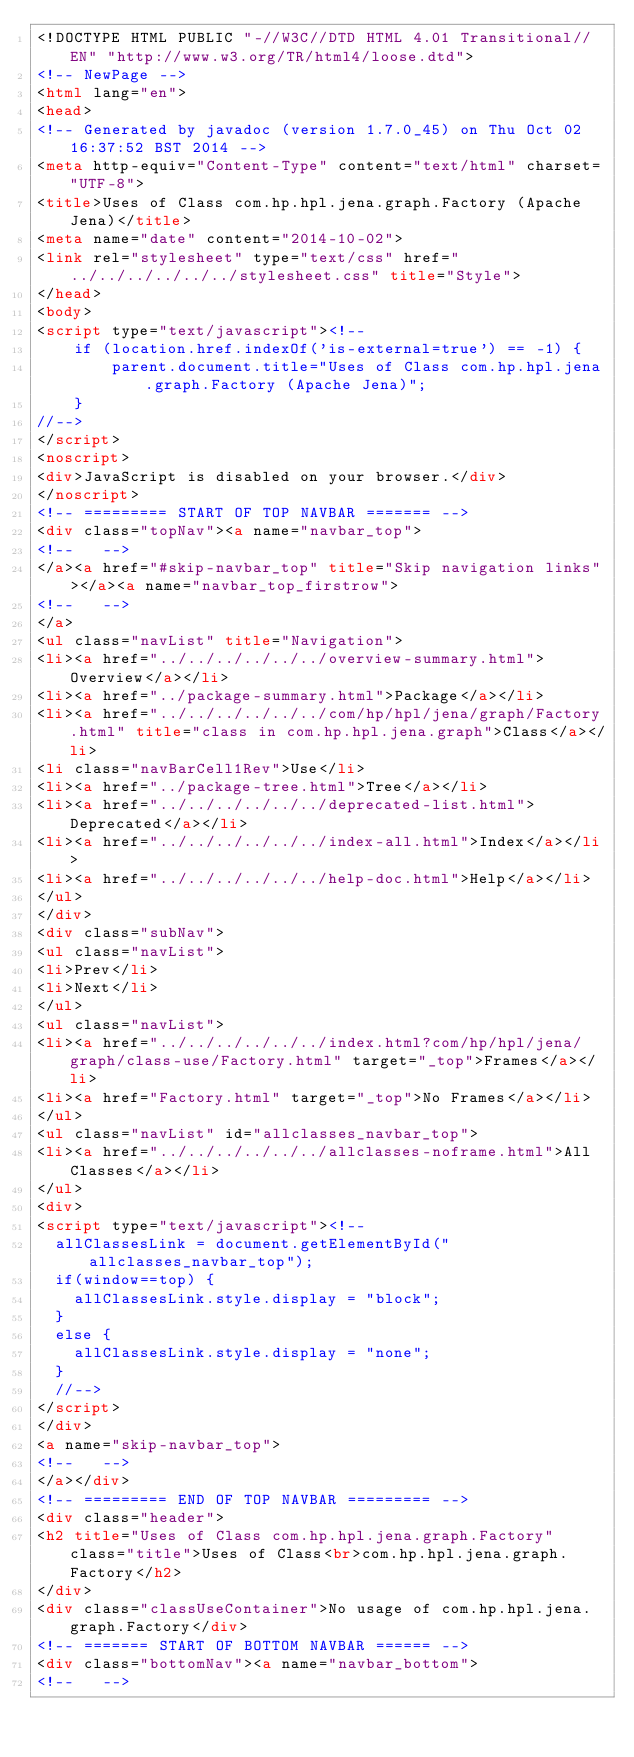<code> <loc_0><loc_0><loc_500><loc_500><_HTML_><!DOCTYPE HTML PUBLIC "-//W3C//DTD HTML 4.01 Transitional//EN" "http://www.w3.org/TR/html4/loose.dtd">
<!-- NewPage -->
<html lang="en">
<head>
<!-- Generated by javadoc (version 1.7.0_45) on Thu Oct 02 16:37:52 BST 2014 -->
<meta http-equiv="Content-Type" content="text/html" charset="UTF-8">
<title>Uses of Class com.hp.hpl.jena.graph.Factory (Apache Jena)</title>
<meta name="date" content="2014-10-02">
<link rel="stylesheet" type="text/css" href="../../../../../../stylesheet.css" title="Style">
</head>
<body>
<script type="text/javascript"><!--
    if (location.href.indexOf('is-external=true') == -1) {
        parent.document.title="Uses of Class com.hp.hpl.jena.graph.Factory (Apache Jena)";
    }
//-->
</script>
<noscript>
<div>JavaScript is disabled on your browser.</div>
</noscript>
<!-- ========= START OF TOP NAVBAR ======= -->
<div class="topNav"><a name="navbar_top">
<!--   -->
</a><a href="#skip-navbar_top" title="Skip navigation links"></a><a name="navbar_top_firstrow">
<!--   -->
</a>
<ul class="navList" title="Navigation">
<li><a href="../../../../../../overview-summary.html">Overview</a></li>
<li><a href="../package-summary.html">Package</a></li>
<li><a href="../../../../../../com/hp/hpl/jena/graph/Factory.html" title="class in com.hp.hpl.jena.graph">Class</a></li>
<li class="navBarCell1Rev">Use</li>
<li><a href="../package-tree.html">Tree</a></li>
<li><a href="../../../../../../deprecated-list.html">Deprecated</a></li>
<li><a href="../../../../../../index-all.html">Index</a></li>
<li><a href="../../../../../../help-doc.html">Help</a></li>
</ul>
</div>
<div class="subNav">
<ul class="navList">
<li>Prev</li>
<li>Next</li>
</ul>
<ul class="navList">
<li><a href="../../../../../../index.html?com/hp/hpl/jena/graph/class-use/Factory.html" target="_top">Frames</a></li>
<li><a href="Factory.html" target="_top">No Frames</a></li>
</ul>
<ul class="navList" id="allclasses_navbar_top">
<li><a href="../../../../../../allclasses-noframe.html">All Classes</a></li>
</ul>
<div>
<script type="text/javascript"><!--
  allClassesLink = document.getElementById("allclasses_navbar_top");
  if(window==top) {
    allClassesLink.style.display = "block";
  }
  else {
    allClassesLink.style.display = "none";
  }
  //-->
</script>
</div>
<a name="skip-navbar_top">
<!--   -->
</a></div>
<!-- ========= END OF TOP NAVBAR ========= -->
<div class="header">
<h2 title="Uses of Class com.hp.hpl.jena.graph.Factory" class="title">Uses of Class<br>com.hp.hpl.jena.graph.Factory</h2>
</div>
<div class="classUseContainer">No usage of com.hp.hpl.jena.graph.Factory</div>
<!-- ======= START OF BOTTOM NAVBAR ====== -->
<div class="bottomNav"><a name="navbar_bottom">
<!--   --></code> 